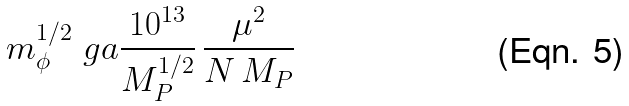Convert formula to latex. <formula><loc_0><loc_0><loc_500><loc_500>m _ { \phi } ^ { 1 / 2 } \ g a \frac { 1 0 ^ { 1 3 } } { M _ { P } ^ { 1 / 2 } } \, \frac { \mu ^ { 2 } } { N \, M _ { P } }</formula> 